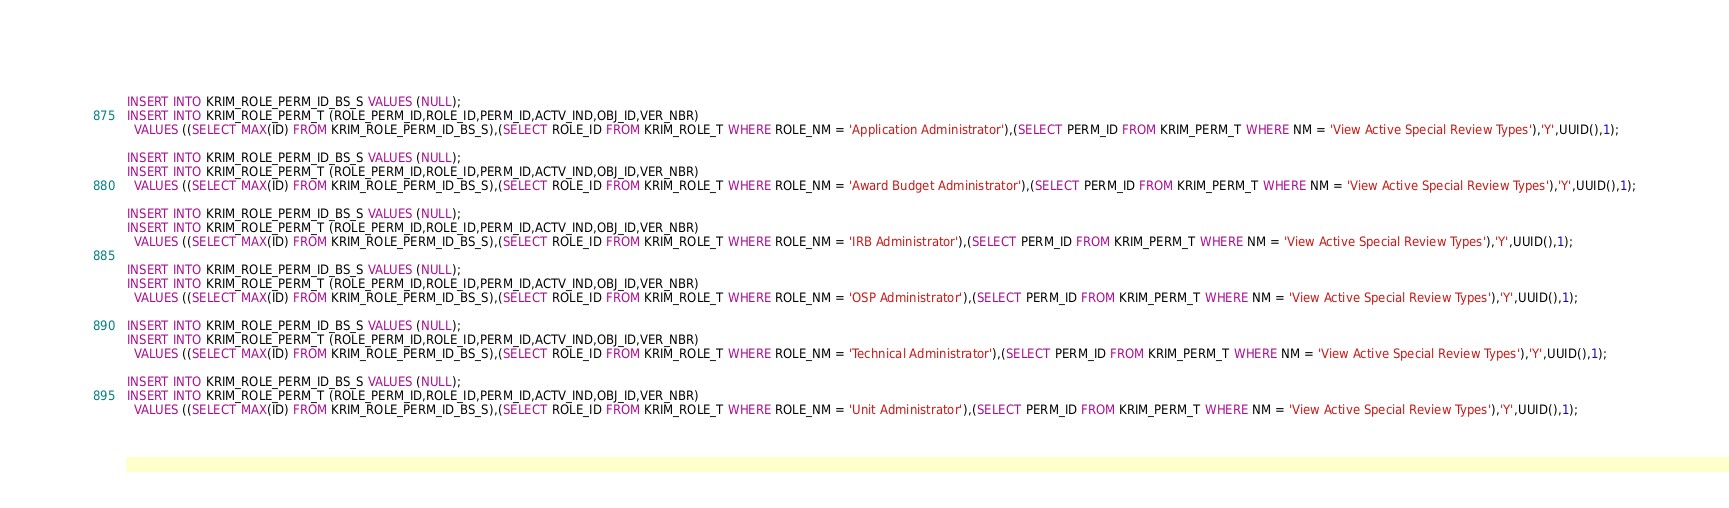<code> <loc_0><loc_0><loc_500><loc_500><_SQL_>INSERT INTO KRIM_ROLE_PERM_ID_BS_S VALUES (NULL);
INSERT INTO KRIM_ROLE_PERM_T (ROLE_PERM_ID,ROLE_ID,PERM_ID,ACTV_IND,OBJ_ID,VER_NBR)
  VALUES ((SELECT MAX(ID) FROM KRIM_ROLE_PERM_ID_BS_S),(SELECT ROLE_ID FROM KRIM_ROLE_T WHERE ROLE_NM = 'Application Administrator'),(SELECT PERM_ID FROM KRIM_PERM_T WHERE NM = 'View Active Special Review Types'),'Y',UUID(),1);

INSERT INTO KRIM_ROLE_PERM_ID_BS_S VALUES (NULL);
INSERT INTO KRIM_ROLE_PERM_T (ROLE_PERM_ID,ROLE_ID,PERM_ID,ACTV_IND,OBJ_ID,VER_NBR)
  VALUES ((SELECT MAX(ID) FROM KRIM_ROLE_PERM_ID_BS_S),(SELECT ROLE_ID FROM KRIM_ROLE_T WHERE ROLE_NM = 'Award Budget Administrator'),(SELECT PERM_ID FROM KRIM_PERM_T WHERE NM = 'View Active Special Review Types'),'Y',UUID(),1);

INSERT INTO KRIM_ROLE_PERM_ID_BS_S VALUES (NULL);
INSERT INTO KRIM_ROLE_PERM_T (ROLE_PERM_ID,ROLE_ID,PERM_ID,ACTV_IND,OBJ_ID,VER_NBR)
  VALUES ((SELECT MAX(ID) FROM KRIM_ROLE_PERM_ID_BS_S),(SELECT ROLE_ID FROM KRIM_ROLE_T WHERE ROLE_NM = 'IRB Administrator'),(SELECT PERM_ID FROM KRIM_PERM_T WHERE NM = 'View Active Special Review Types'),'Y',UUID(),1);

INSERT INTO KRIM_ROLE_PERM_ID_BS_S VALUES (NULL);
INSERT INTO KRIM_ROLE_PERM_T (ROLE_PERM_ID,ROLE_ID,PERM_ID,ACTV_IND,OBJ_ID,VER_NBR)
  VALUES ((SELECT MAX(ID) FROM KRIM_ROLE_PERM_ID_BS_S),(SELECT ROLE_ID FROM KRIM_ROLE_T WHERE ROLE_NM = 'OSP Administrator'),(SELECT PERM_ID FROM KRIM_PERM_T WHERE NM = 'View Active Special Review Types'),'Y',UUID(),1);
  
INSERT INTO KRIM_ROLE_PERM_ID_BS_S VALUES (NULL);
INSERT INTO KRIM_ROLE_PERM_T (ROLE_PERM_ID,ROLE_ID,PERM_ID,ACTV_IND,OBJ_ID,VER_NBR)
  VALUES ((SELECT MAX(ID) FROM KRIM_ROLE_PERM_ID_BS_S),(SELECT ROLE_ID FROM KRIM_ROLE_T WHERE ROLE_NM = 'Technical Administrator'),(SELECT PERM_ID FROM KRIM_PERM_T WHERE NM = 'View Active Special Review Types'),'Y',UUID(),1);

INSERT INTO KRIM_ROLE_PERM_ID_BS_S VALUES (NULL);
INSERT INTO KRIM_ROLE_PERM_T (ROLE_PERM_ID,ROLE_ID,PERM_ID,ACTV_IND,OBJ_ID,VER_NBR)
  VALUES ((SELECT MAX(ID) FROM KRIM_ROLE_PERM_ID_BS_S),(SELECT ROLE_ID FROM KRIM_ROLE_T WHERE ROLE_NM = 'Unit Administrator'),(SELECT PERM_ID FROM KRIM_PERM_T WHERE NM = 'View Active Special Review Types'),'Y',UUID(),1);</code> 